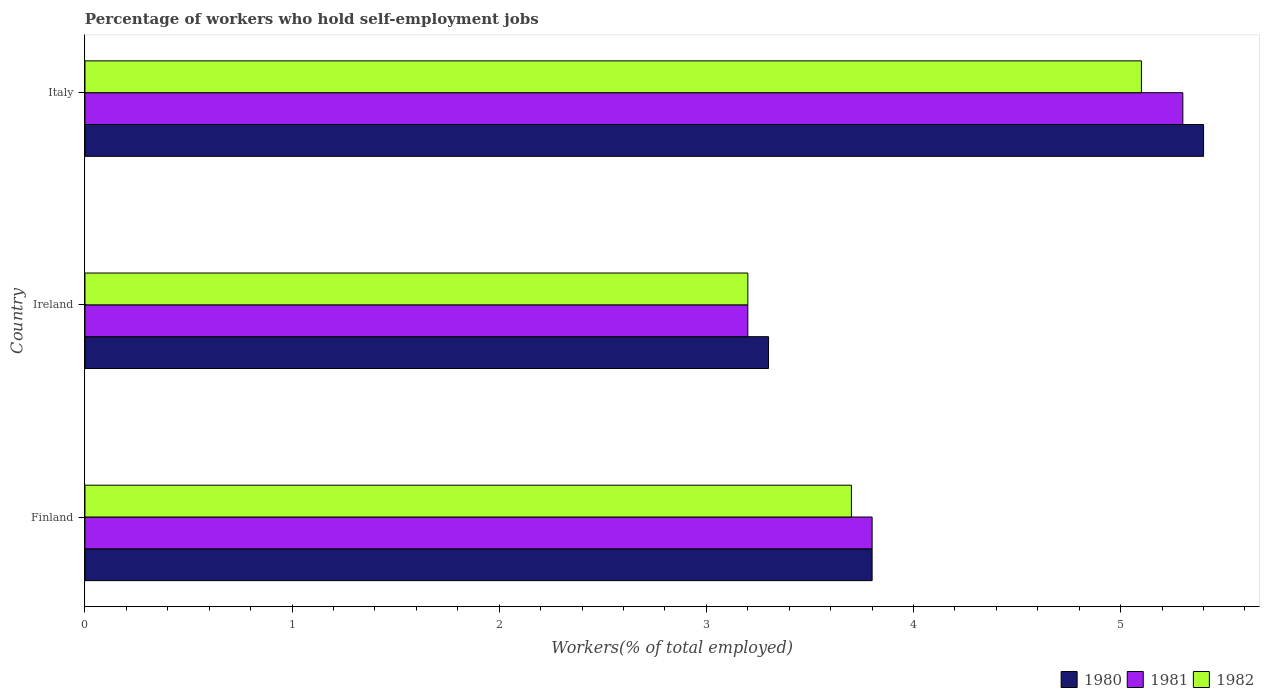How many groups of bars are there?
Keep it short and to the point. 3. How many bars are there on the 2nd tick from the top?
Give a very brief answer. 3. What is the label of the 2nd group of bars from the top?
Offer a terse response. Ireland. In how many cases, is the number of bars for a given country not equal to the number of legend labels?
Make the answer very short. 0. What is the percentage of self-employed workers in 1981 in Ireland?
Your answer should be very brief. 3.2. Across all countries, what is the maximum percentage of self-employed workers in 1982?
Your response must be concise. 5.1. Across all countries, what is the minimum percentage of self-employed workers in 1980?
Make the answer very short. 3.3. In which country was the percentage of self-employed workers in 1981 maximum?
Your answer should be very brief. Italy. In which country was the percentage of self-employed workers in 1980 minimum?
Your response must be concise. Ireland. What is the total percentage of self-employed workers in 1980 in the graph?
Offer a very short reply. 12.5. What is the difference between the percentage of self-employed workers in 1981 in Finland and that in Italy?
Give a very brief answer. -1.5. What is the difference between the percentage of self-employed workers in 1980 in Italy and the percentage of self-employed workers in 1982 in Ireland?
Make the answer very short. 2.2. What is the average percentage of self-employed workers in 1982 per country?
Your answer should be compact. 4. What is the difference between the percentage of self-employed workers in 1982 and percentage of self-employed workers in 1980 in Finland?
Keep it short and to the point. -0.1. In how many countries, is the percentage of self-employed workers in 1980 greater than 0.6000000000000001 %?
Provide a succinct answer. 3. What is the ratio of the percentage of self-employed workers in 1980 in Finland to that in Ireland?
Keep it short and to the point. 1.15. What is the difference between the highest and the second highest percentage of self-employed workers in 1980?
Your answer should be very brief. 1.6. What is the difference between the highest and the lowest percentage of self-employed workers in 1981?
Keep it short and to the point. 2.1. What does the 2nd bar from the bottom in Ireland represents?
Offer a terse response. 1981. What is the difference between two consecutive major ticks on the X-axis?
Ensure brevity in your answer.  1. Are the values on the major ticks of X-axis written in scientific E-notation?
Your answer should be compact. No. Does the graph contain any zero values?
Offer a very short reply. No. Does the graph contain grids?
Ensure brevity in your answer.  No. Where does the legend appear in the graph?
Your response must be concise. Bottom right. How are the legend labels stacked?
Your response must be concise. Horizontal. What is the title of the graph?
Provide a short and direct response. Percentage of workers who hold self-employment jobs. Does "1971" appear as one of the legend labels in the graph?
Give a very brief answer. No. What is the label or title of the X-axis?
Make the answer very short. Workers(% of total employed). What is the label or title of the Y-axis?
Keep it short and to the point. Country. What is the Workers(% of total employed) of 1980 in Finland?
Your answer should be very brief. 3.8. What is the Workers(% of total employed) of 1981 in Finland?
Keep it short and to the point. 3.8. What is the Workers(% of total employed) of 1982 in Finland?
Offer a terse response. 3.7. What is the Workers(% of total employed) of 1980 in Ireland?
Make the answer very short. 3.3. What is the Workers(% of total employed) in 1981 in Ireland?
Offer a terse response. 3.2. What is the Workers(% of total employed) in 1982 in Ireland?
Offer a very short reply. 3.2. What is the Workers(% of total employed) in 1980 in Italy?
Offer a very short reply. 5.4. What is the Workers(% of total employed) of 1981 in Italy?
Provide a succinct answer. 5.3. What is the Workers(% of total employed) of 1982 in Italy?
Provide a succinct answer. 5.1. Across all countries, what is the maximum Workers(% of total employed) in 1980?
Make the answer very short. 5.4. Across all countries, what is the maximum Workers(% of total employed) in 1981?
Provide a succinct answer. 5.3. Across all countries, what is the maximum Workers(% of total employed) in 1982?
Your response must be concise. 5.1. Across all countries, what is the minimum Workers(% of total employed) of 1980?
Make the answer very short. 3.3. Across all countries, what is the minimum Workers(% of total employed) of 1981?
Offer a terse response. 3.2. Across all countries, what is the minimum Workers(% of total employed) of 1982?
Ensure brevity in your answer.  3.2. What is the total Workers(% of total employed) in 1980 in the graph?
Give a very brief answer. 12.5. What is the difference between the Workers(% of total employed) of 1980 in Finland and that in Ireland?
Offer a very short reply. 0.5. What is the difference between the Workers(% of total employed) in 1981 in Finland and that in Ireland?
Provide a short and direct response. 0.6. What is the difference between the Workers(% of total employed) in 1980 in Finland and that in Italy?
Keep it short and to the point. -1.6. What is the difference between the Workers(% of total employed) of 1981 in Finland and that in Italy?
Make the answer very short. -1.5. What is the difference between the Workers(% of total employed) in 1982 in Finland and that in Italy?
Your answer should be compact. -1.4. What is the difference between the Workers(% of total employed) of 1981 in Ireland and that in Italy?
Keep it short and to the point. -2.1. What is the difference between the Workers(% of total employed) of 1982 in Ireland and that in Italy?
Your response must be concise. -1.9. What is the difference between the Workers(% of total employed) in 1980 in Finland and the Workers(% of total employed) in 1982 in Ireland?
Ensure brevity in your answer.  0.6. What is the difference between the Workers(% of total employed) of 1981 in Finland and the Workers(% of total employed) of 1982 in Ireland?
Offer a very short reply. 0.6. What is the difference between the Workers(% of total employed) in 1980 in Finland and the Workers(% of total employed) in 1981 in Italy?
Offer a very short reply. -1.5. What is the difference between the Workers(% of total employed) of 1980 in Finland and the Workers(% of total employed) of 1982 in Italy?
Offer a very short reply. -1.3. What is the average Workers(% of total employed) of 1980 per country?
Your answer should be compact. 4.17. What is the average Workers(% of total employed) in 1982 per country?
Make the answer very short. 4. What is the difference between the Workers(% of total employed) of 1980 and Workers(% of total employed) of 1981 in Finland?
Offer a very short reply. 0. What is the difference between the Workers(% of total employed) in 1980 and Workers(% of total employed) in 1982 in Finland?
Your response must be concise. 0.1. What is the difference between the Workers(% of total employed) in 1981 and Workers(% of total employed) in 1982 in Finland?
Offer a terse response. 0.1. What is the difference between the Workers(% of total employed) of 1980 and Workers(% of total employed) of 1981 in Italy?
Provide a succinct answer. 0.1. What is the difference between the Workers(% of total employed) of 1980 and Workers(% of total employed) of 1982 in Italy?
Provide a succinct answer. 0.3. What is the ratio of the Workers(% of total employed) of 1980 in Finland to that in Ireland?
Provide a succinct answer. 1.15. What is the ratio of the Workers(% of total employed) of 1981 in Finland to that in Ireland?
Make the answer very short. 1.19. What is the ratio of the Workers(% of total employed) in 1982 in Finland to that in Ireland?
Provide a succinct answer. 1.16. What is the ratio of the Workers(% of total employed) in 1980 in Finland to that in Italy?
Offer a terse response. 0.7. What is the ratio of the Workers(% of total employed) in 1981 in Finland to that in Italy?
Keep it short and to the point. 0.72. What is the ratio of the Workers(% of total employed) in 1982 in Finland to that in Italy?
Your answer should be compact. 0.73. What is the ratio of the Workers(% of total employed) in 1980 in Ireland to that in Italy?
Offer a very short reply. 0.61. What is the ratio of the Workers(% of total employed) of 1981 in Ireland to that in Italy?
Provide a short and direct response. 0.6. What is the ratio of the Workers(% of total employed) of 1982 in Ireland to that in Italy?
Provide a succinct answer. 0.63. What is the difference between the highest and the lowest Workers(% of total employed) in 1981?
Your answer should be very brief. 2.1. What is the difference between the highest and the lowest Workers(% of total employed) in 1982?
Keep it short and to the point. 1.9. 